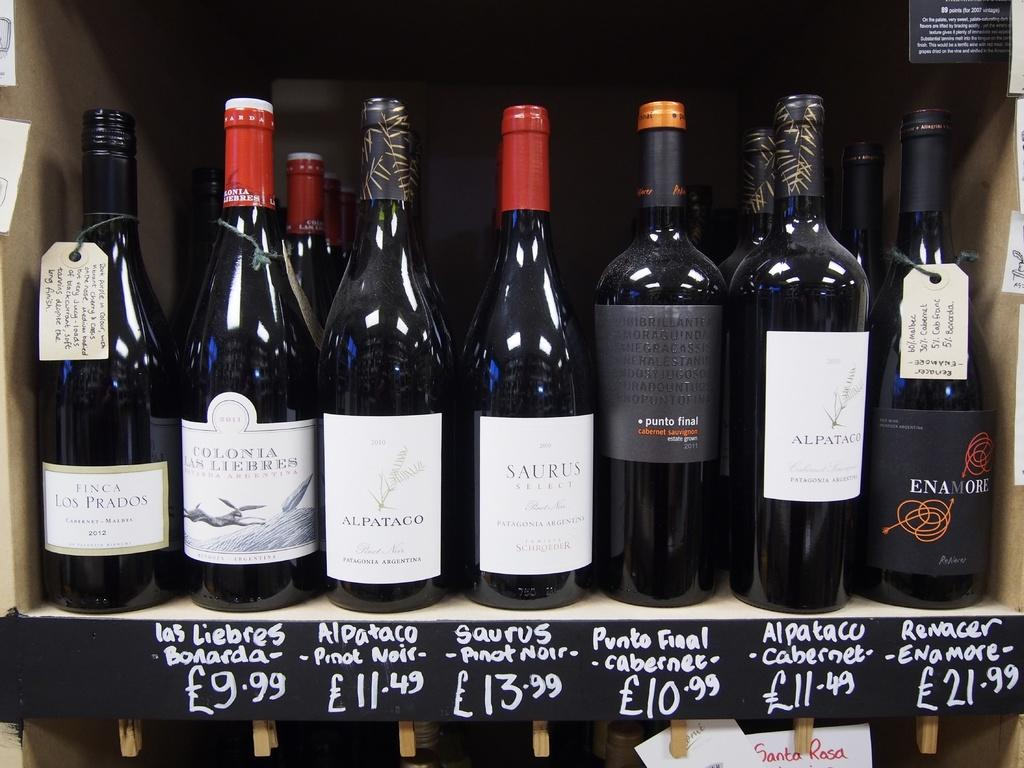<image>
Describe the image concisely. Wines are displayed for ales, including Alpataco for 11.49. 